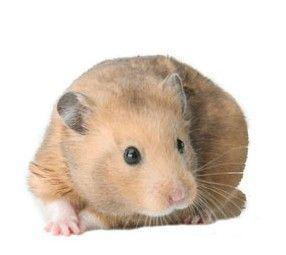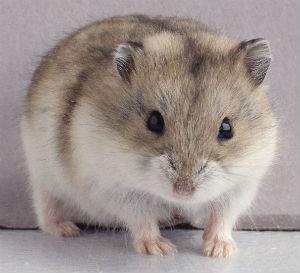The first image is the image on the left, the second image is the image on the right. Given the left and right images, does the statement "A human hand is holding a hamster in at least one of the images." hold true? Answer yes or no. No. The first image is the image on the left, the second image is the image on the right. Evaluate the accuracy of this statement regarding the images: "A hamster is being held in someone's hand.". Is it true? Answer yes or no. No. The first image is the image on the left, the second image is the image on the right. Given the left and right images, does the statement "One outstretched palm holds a hamster that is standing and looking toward the camera." hold true? Answer yes or no. No. The first image is the image on the left, the second image is the image on the right. Evaluate the accuracy of this statement regarding the images: "In one image the hamster is held in someone's hand and in the other the hamster is standing on sawdust.". Is it true? Answer yes or no. No. 